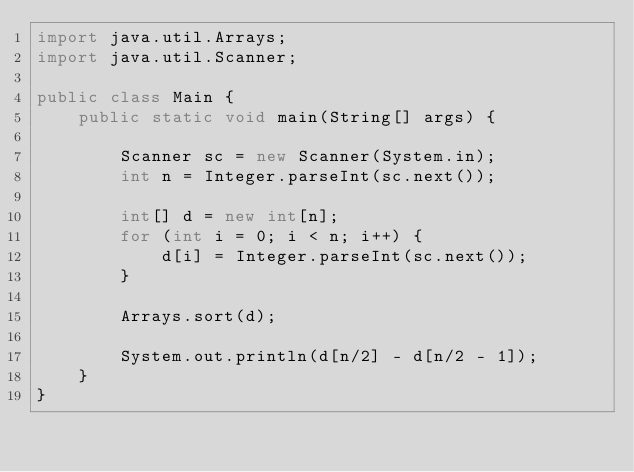<code> <loc_0><loc_0><loc_500><loc_500><_Java_>import java.util.Arrays;
import java.util.Scanner;

public class Main {
    public static void main(String[] args) {

        Scanner sc = new Scanner(System.in);
        int n = Integer.parseInt(sc.next());

        int[] d = new int[n];
        for (int i = 0; i < n; i++) {
            d[i] = Integer.parseInt(sc.next());
        }

        Arrays.sort(d);

        System.out.println(d[n/2] - d[n/2 - 1]);
    }
}</code> 